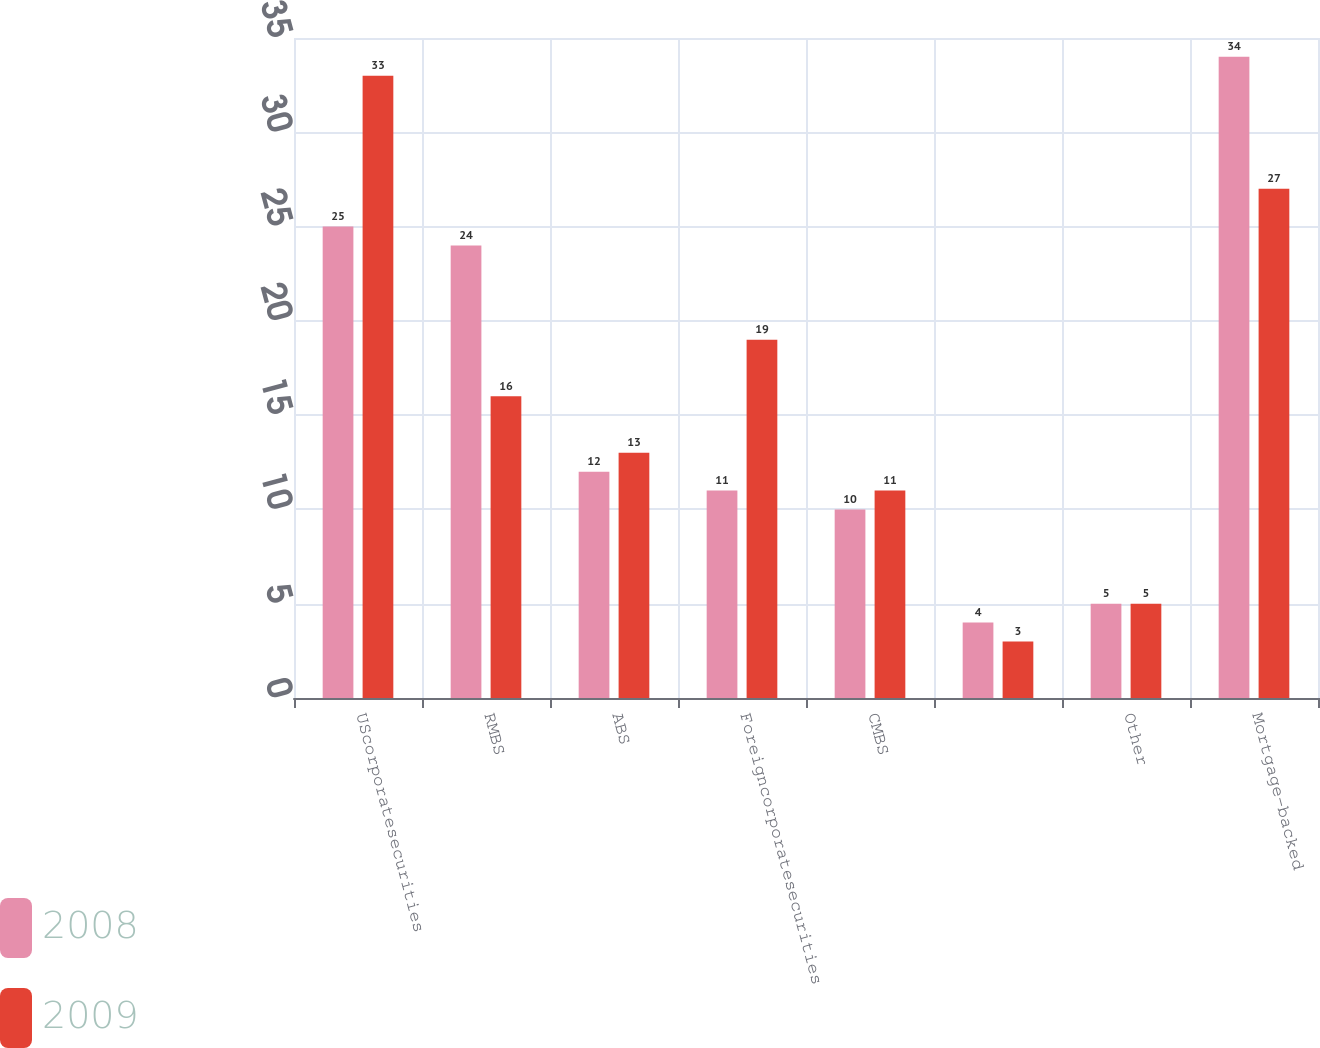<chart> <loc_0><loc_0><loc_500><loc_500><stacked_bar_chart><ecel><fcel>UScorporatesecurities<fcel>RMBS<fcel>ABS<fcel>Foreigncorporatesecurities<fcel>CMBS<fcel>Unnamed: 6<fcel>Other<fcel>Mortgage-backed<nl><fcel>2008<fcel>25<fcel>24<fcel>12<fcel>11<fcel>10<fcel>4<fcel>5<fcel>34<nl><fcel>2009<fcel>33<fcel>16<fcel>13<fcel>19<fcel>11<fcel>3<fcel>5<fcel>27<nl></chart> 